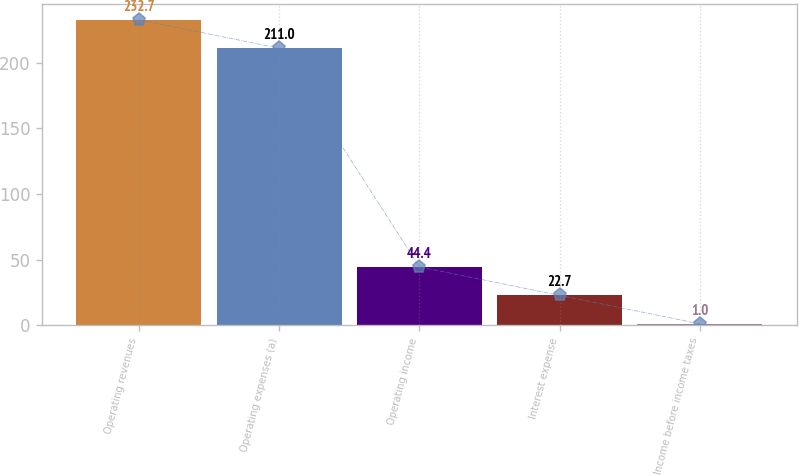Convert chart to OTSL. <chart><loc_0><loc_0><loc_500><loc_500><bar_chart><fcel>Operating revenues<fcel>Operating expenses (a)<fcel>Operating income<fcel>Interest expense<fcel>Income before income taxes<nl><fcel>232.7<fcel>211<fcel>44.4<fcel>22.7<fcel>1<nl></chart> 